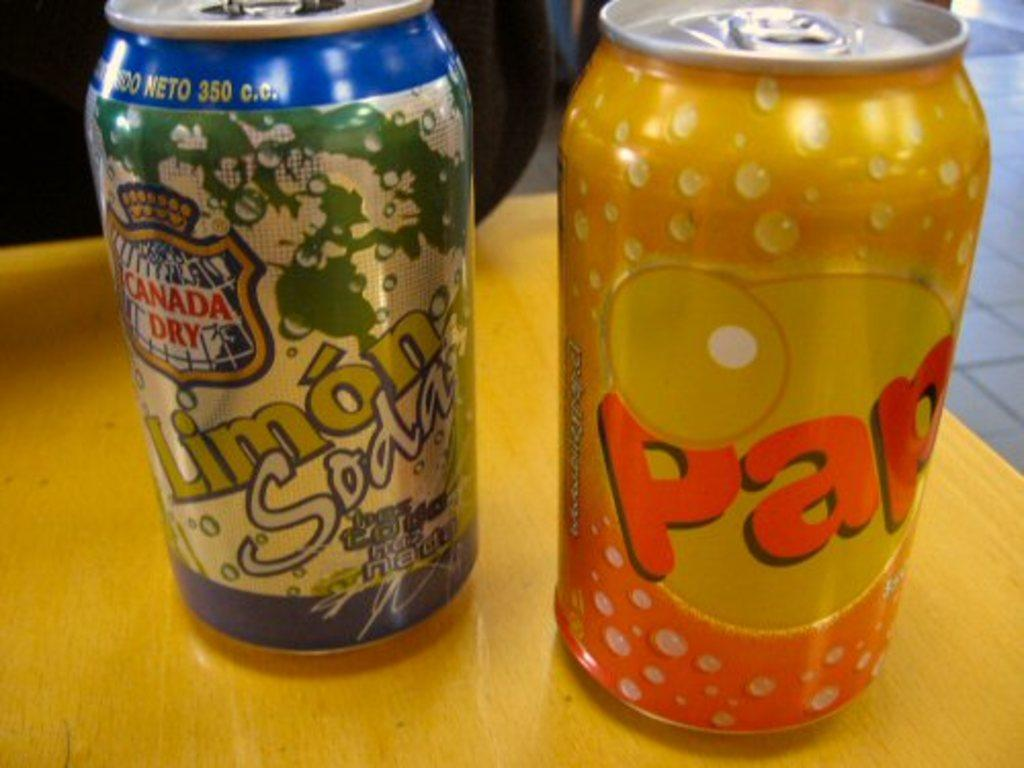<image>
Render a clear and concise summary of the photo. Two cans of beverages, with one being called Pap. 